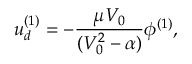<formula> <loc_0><loc_0><loc_500><loc_500>u _ { d } ^ { ( 1 ) } = - \frac { \mu V _ { 0 } } { ( V _ { 0 } ^ { 2 } - \alpha ) } \phi ^ { ( 1 ) } ,</formula> 